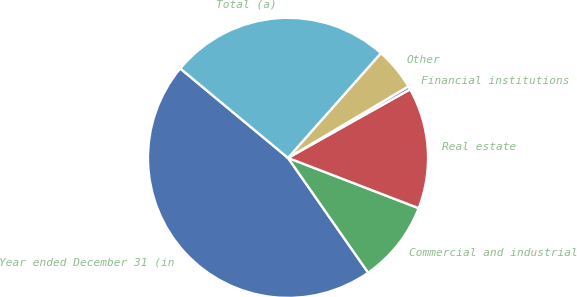<chart> <loc_0><loc_0><loc_500><loc_500><pie_chart><fcel>Year ended December 31 (in<fcel>Commercial and industrial<fcel>Real estate<fcel>Financial institutions<fcel>Other<fcel>Total (a)<nl><fcel>45.72%<fcel>9.45%<fcel>13.99%<fcel>0.39%<fcel>4.92%<fcel>25.53%<nl></chart> 